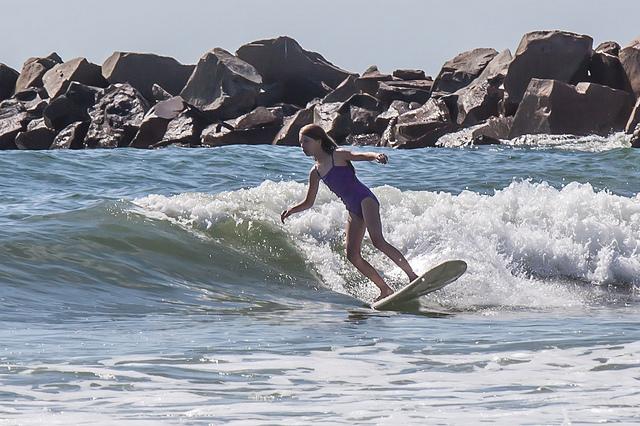What color is the wave?
Short answer required. White. What fruit that grows on a vine is the same color as the bathing suit?
Write a very short answer. Grapes. What is the person doing?
Be succinct. Surfing. 